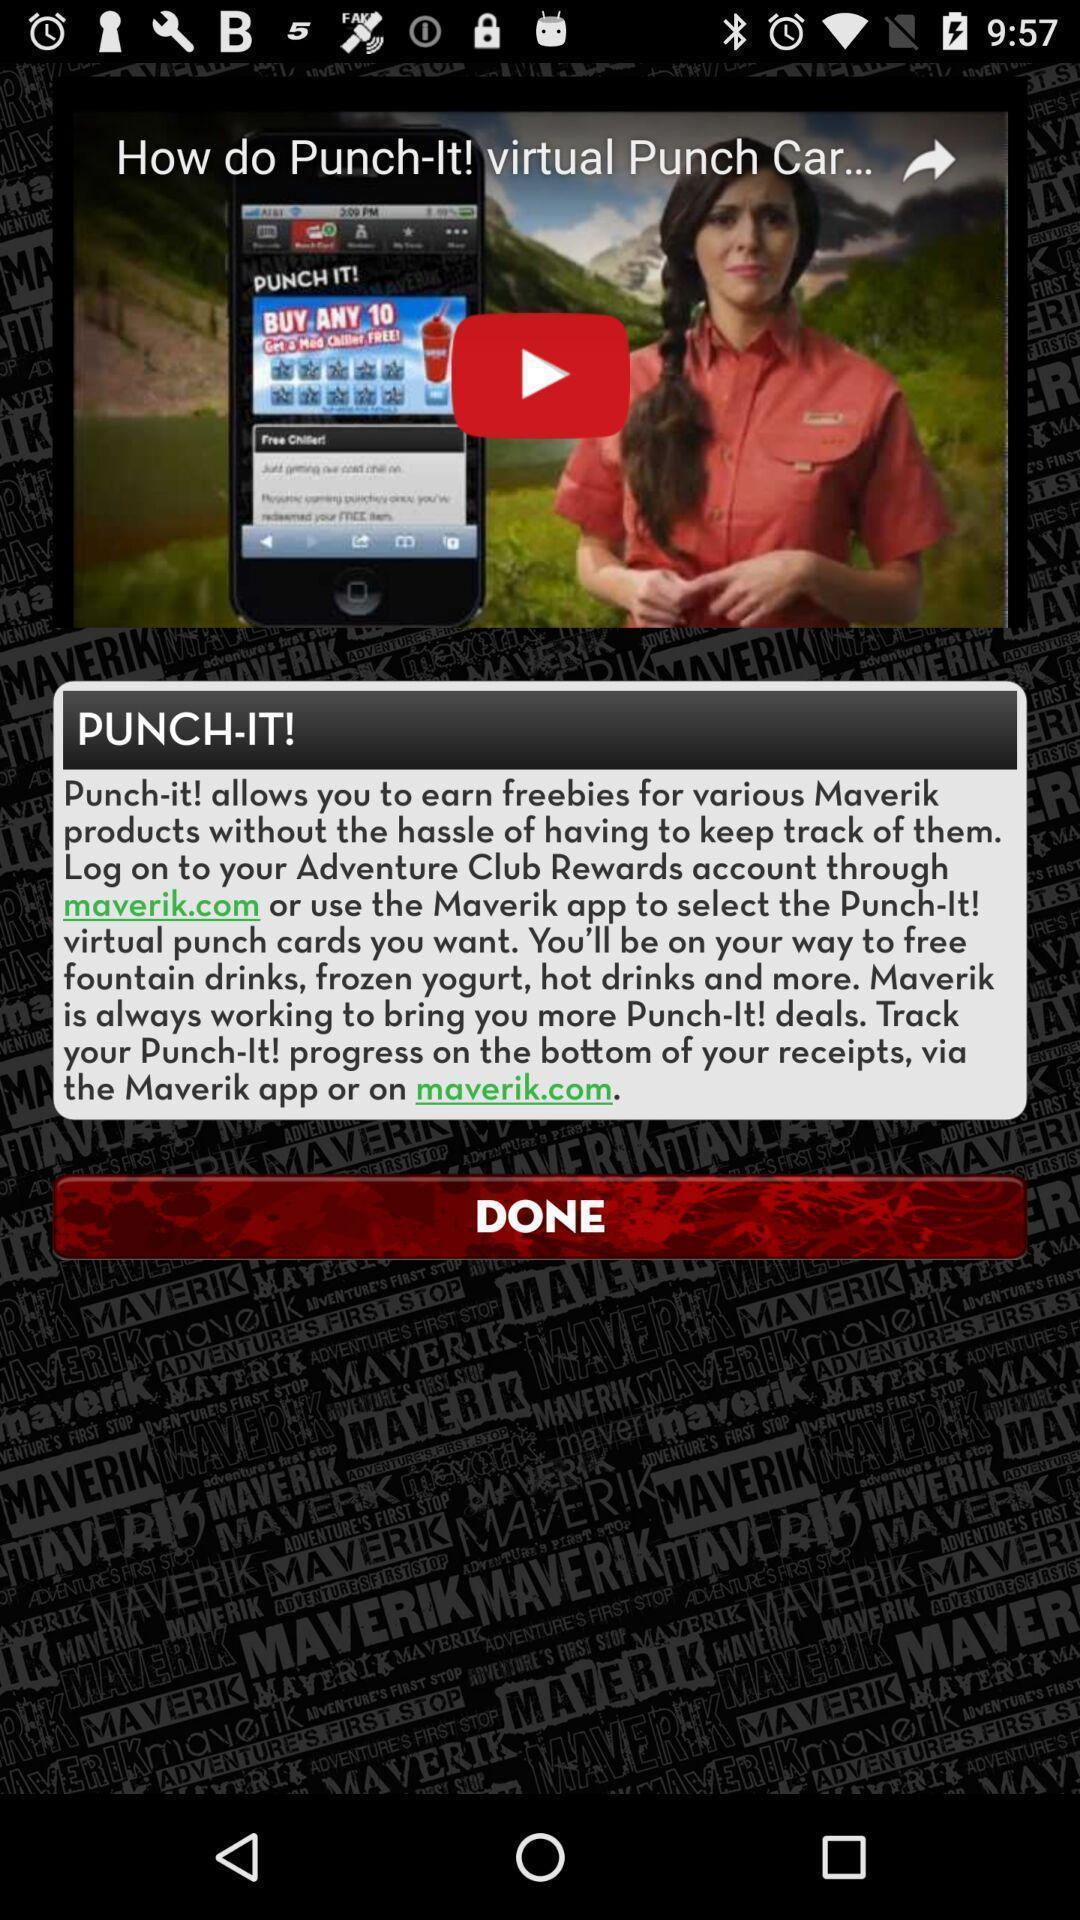Explain the elements present in this screenshot. Page showing video in an application. 